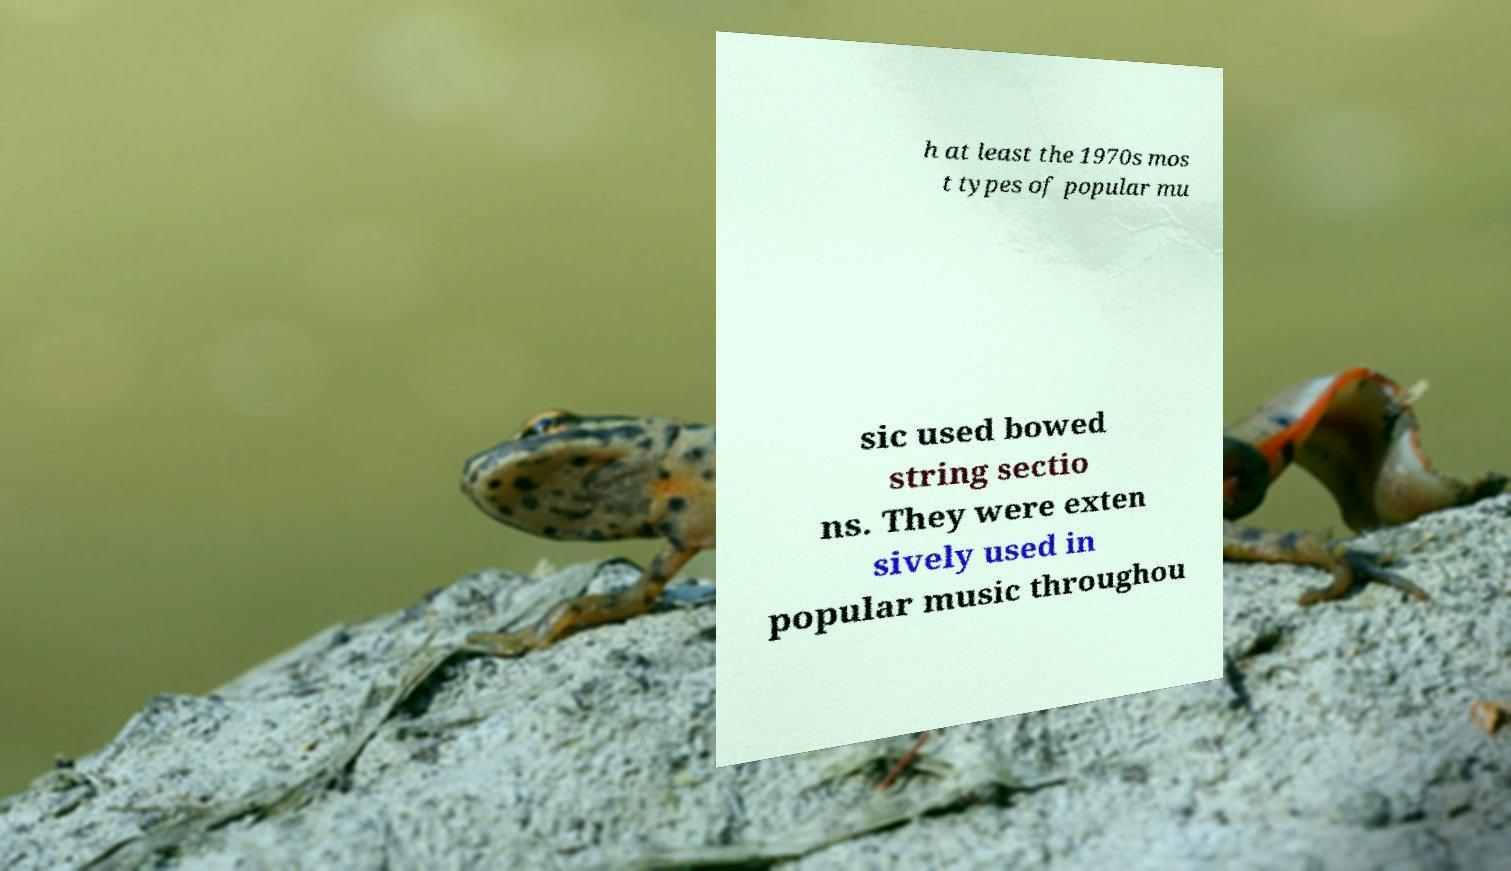There's text embedded in this image that I need extracted. Can you transcribe it verbatim? h at least the 1970s mos t types of popular mu sic used bowed string sectio ns. They were exten sively used in popular music throughou 